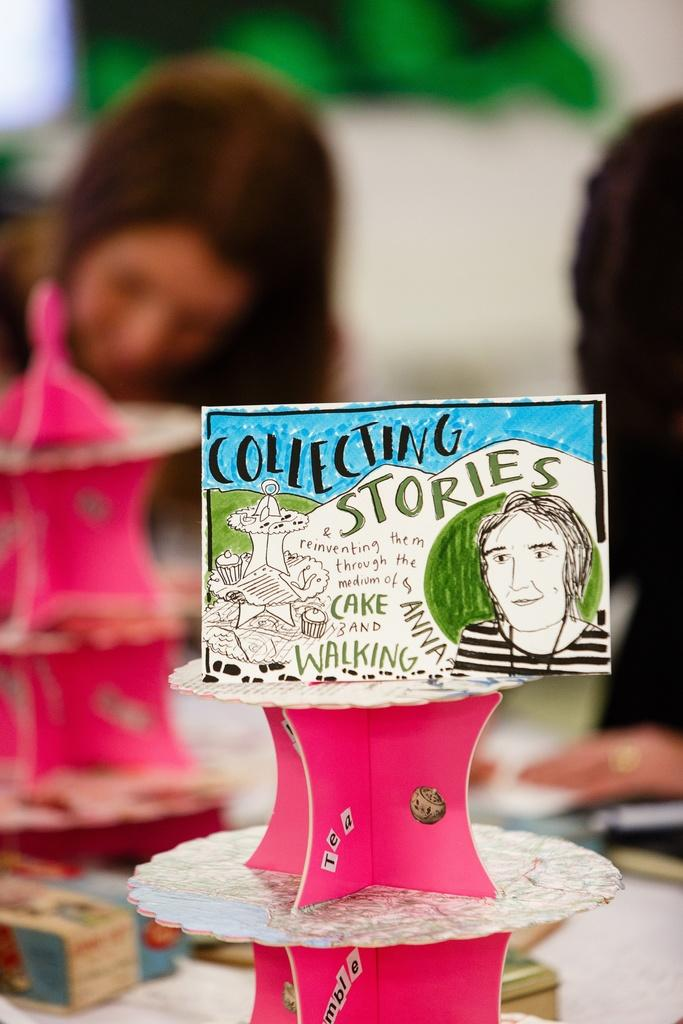What is the main subject of the image? There is a board with text and an image in the image. What color are the objects in the image? There are pink color objects in the image. Can you describe the person in the image? There is a person in the image. How is the background of the person depicted? The background of the person is blurred. What type of building can be seen in the background of the image? There is no building visible in the background of the image. Can you describe the stick that the person is holding in the image? There is no stick present in the image. 